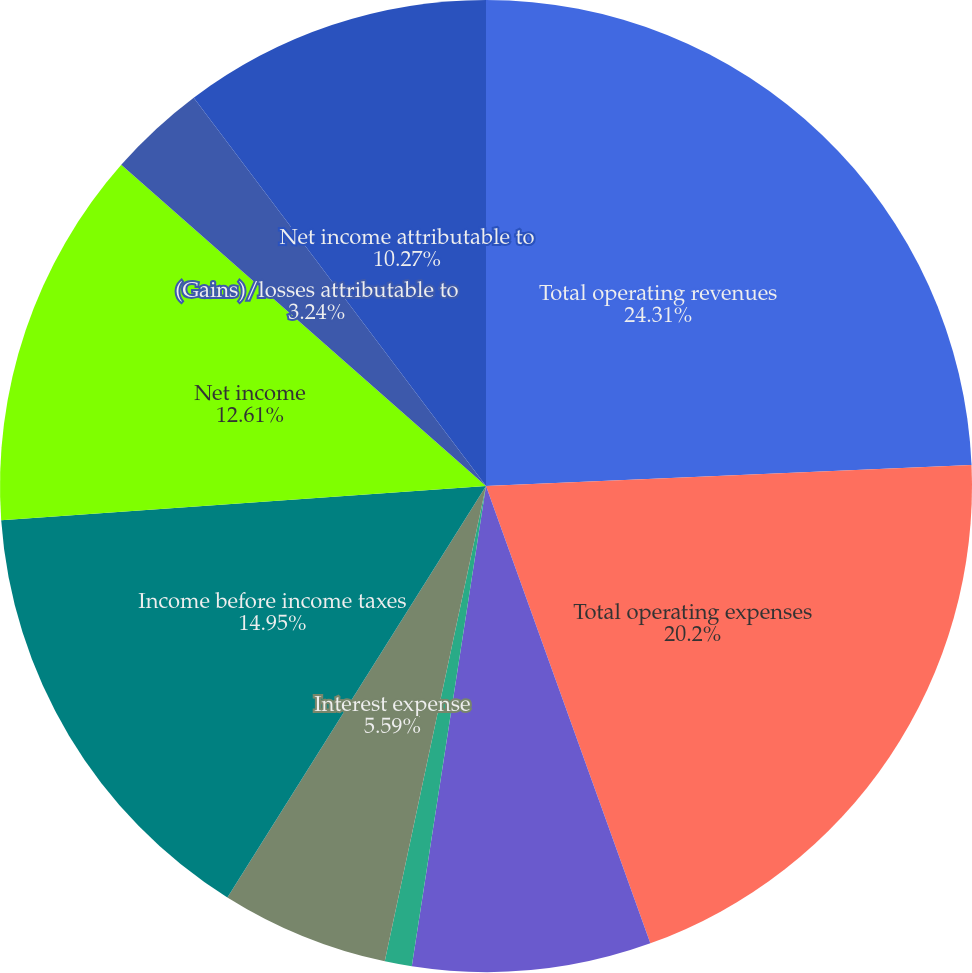Convert chart. <chart><loc_0><loc_0><loc_500><loc_500><pie_chart><fcel>Total operating revenues<fcel>Total operating expenses<fcel>Interest and dividend income<fcel>Other investment<fcel>Interest expense<fcel>Income before income taxes<fcel>Net income<fcel>(Gains)/losses attributable to<fcel>Net income attributable to<nl><fcel>24.31%<fcel>20.2%<fcel>7.93%<fcel>0.9%<fcel>5.59%<fcel>14.95%<fcel>12.61%<fcel>3.24%<fcel>10.27%<nl></chart> 